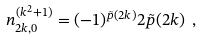Convert formula to latex. <formula><loc_0><loc_0><loc_500><loc_500>n ^ { ( k ^ { 2 } + 1 ) } _ { 2 k , 0 } = ( - 1 ) ^ { { \tilde { p } } ( 2 k ) } 2 { \tilde { p } } ( 2 k ) \ ,</formula> 